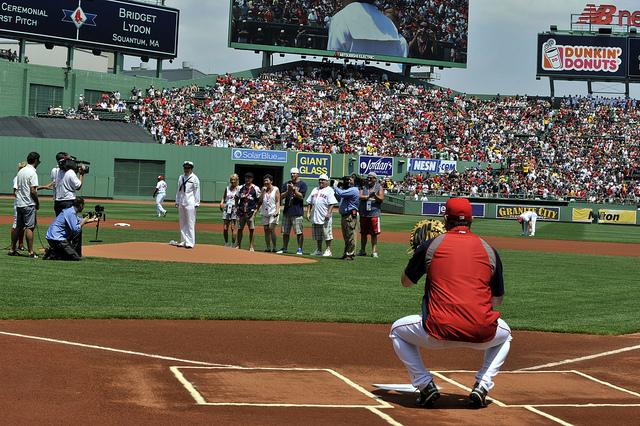What type of pitch is this? Please explain your reasoning. ceremonial pitch. The navy officer is throwing the first pitch. 